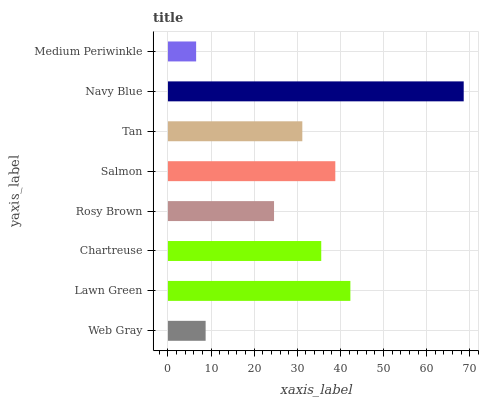Is Medium Periwinkle the minimum?
Answer yes or no. Yes. Is Navy Blue the maximum?
Answer yes or no. Yes. Is Lawn Green the minimum?
Answer yes or no. No. Is Lawn Green the maximum?
Answer yes or no. No. Is Lawn Green greater than Web Gray?
Answer yes or no. Yes. Is Web Gray less than Lawn Green?
Answer yes or no. Yes. Is Web Gray greater than Lawn Green?
Answer yes or no. No. Is Lawn Green less than Web Gray?
Answer yes or no. No. Is Chartreuse the high median?
Answer yes or no. Yes. Is Tan the low median?
Answer yes or no. Yes. Is Navy Blue the high median?
Answer yes or no. No. Is Lawn Green the low median?
Answer yes or no. No. 